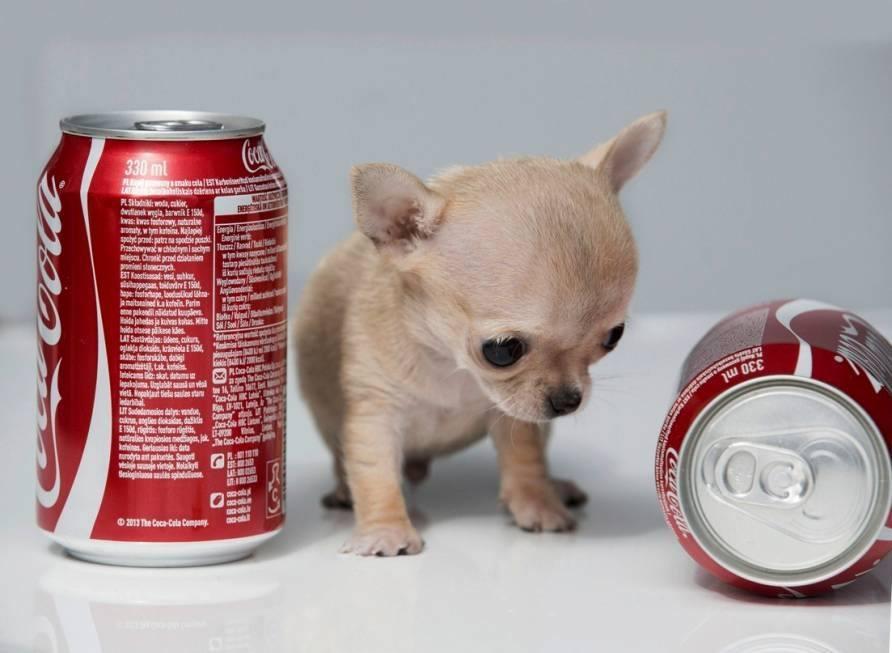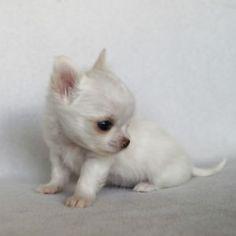The first image is the image on the left, the second image is the image on the right. For the images displayed, is the sentence "A small dog is sitting next to a red object." factually correct? Answer yes or no. Yes. The first image is the image on the left, the second image is the image on the right. For the images displayed, is the sentence "There is a single all white dog in the image on the right." factually correct? Answer yes or no. Yes. 